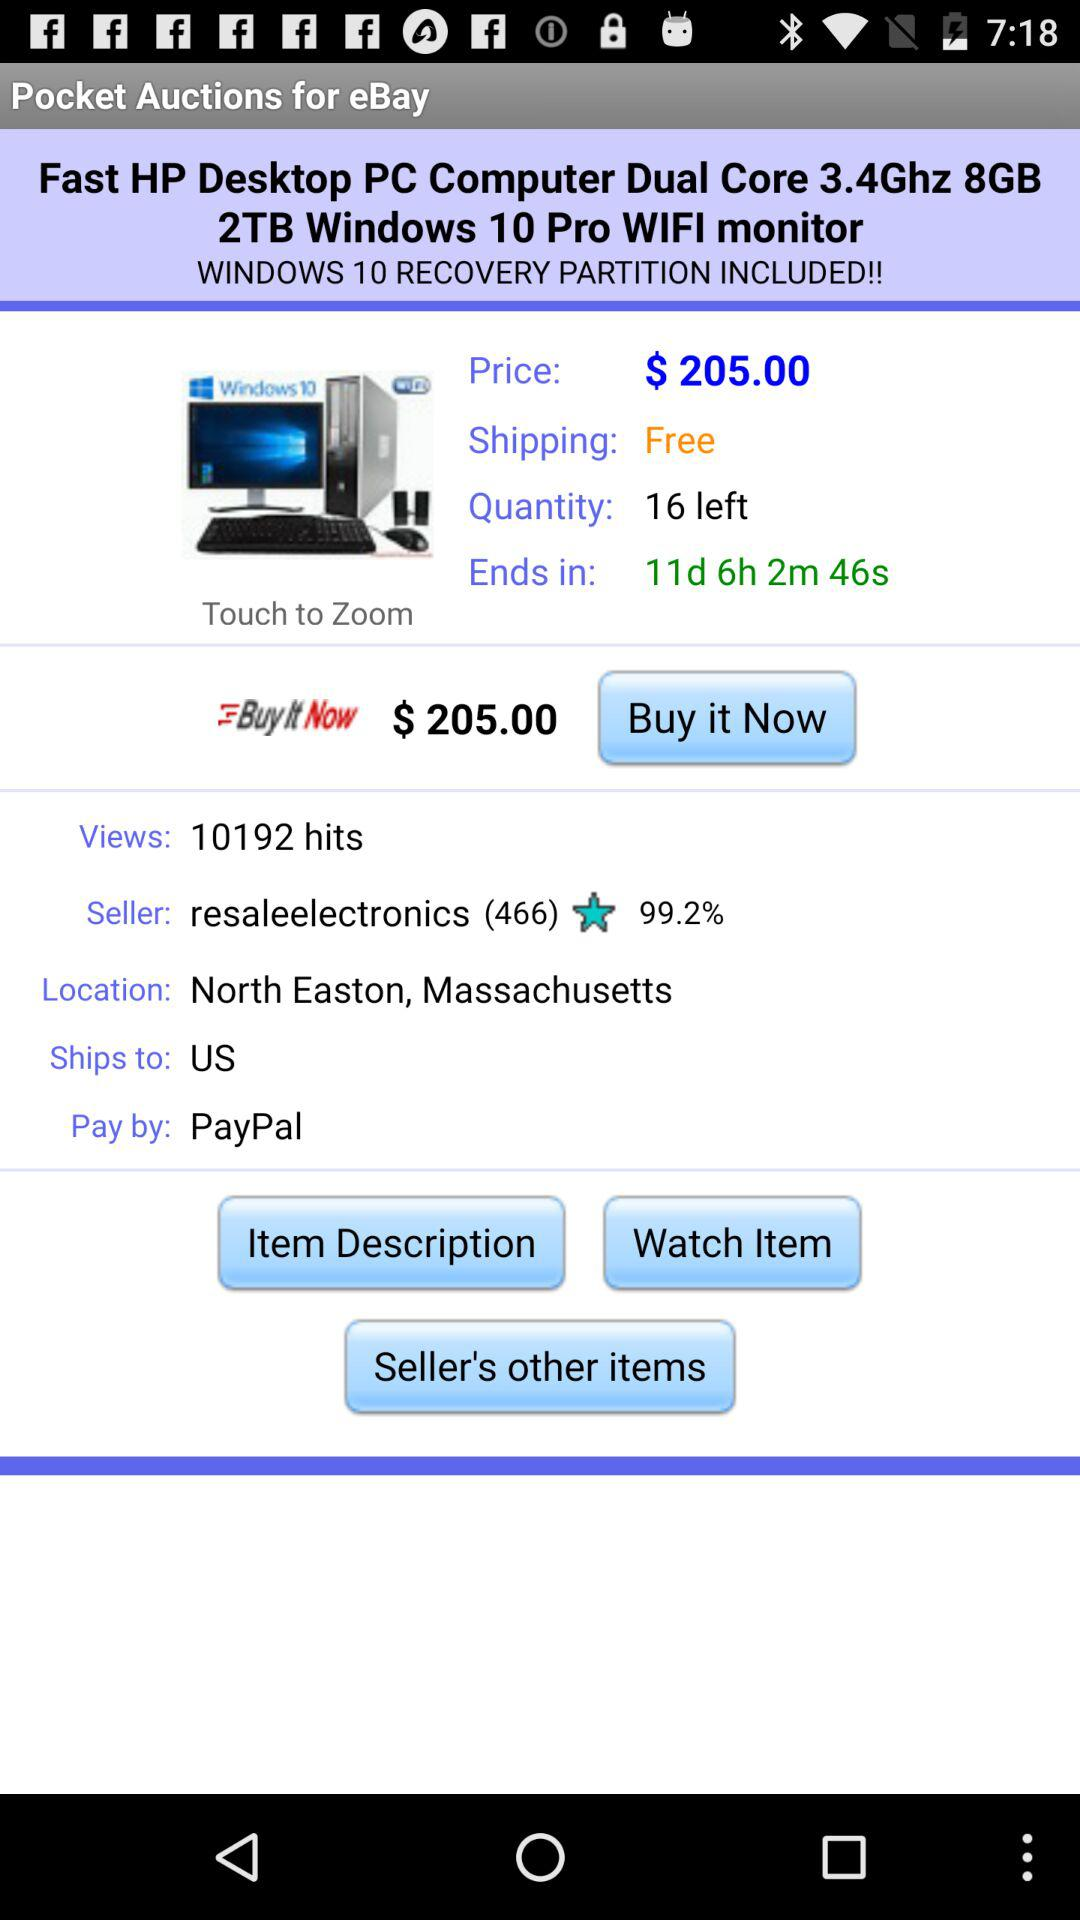What is the cost of shipping?
Answer the question using a single word or phrase. Shipping is free. 